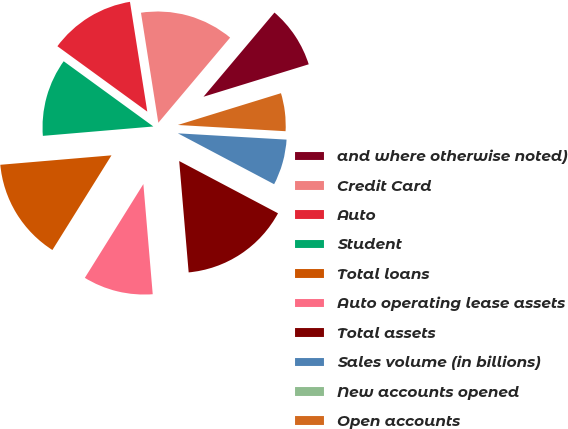Convert chart. <chart><loc_0><loc_0><loc_500><loc_500><pie_chart><fcel>and where otherwise noted)<fcel>Credit Card<fcel>Auto<fcel>Student<fcel>Total loans<fcel>Auto operating lease assets<fcel>Total assets<fcel>Sales volume (in billions)<fcel>New accounts opened<fcel>Open accounts<nl><fcel>9.09%<fcel>13.64%<fcel>12.5%<fcel>11.36%<fcel>14.77%<fcel>10.23%<fcel>15.91%<fcel>6.82%<fcel>0.0%<fcel>5.68%<nl></chart> 